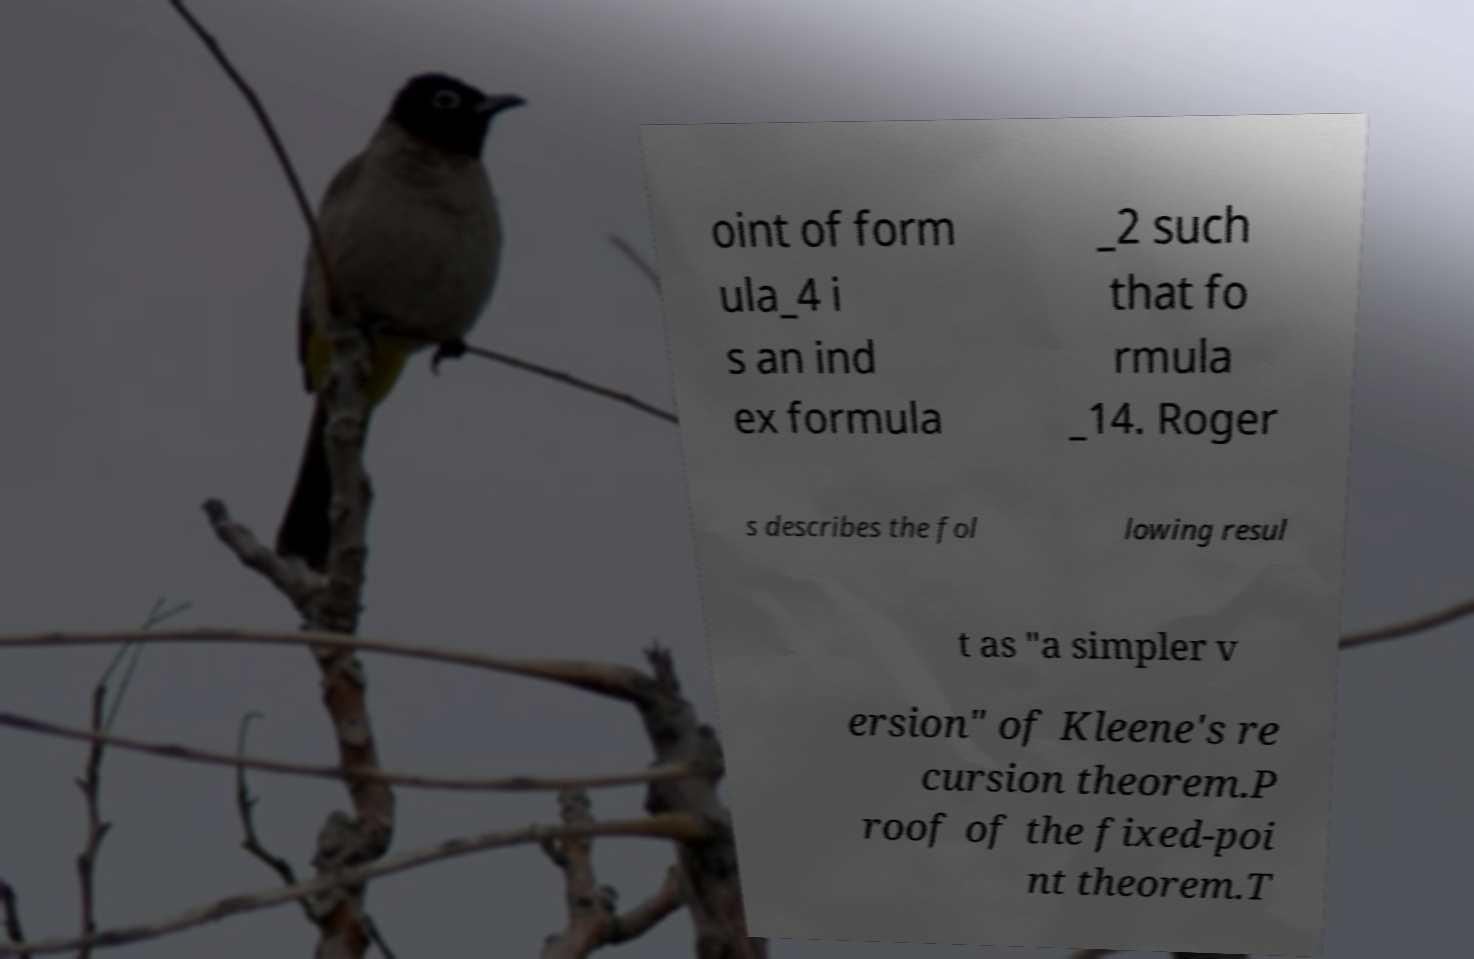Can you read and provide the text displayed in the image?This photo seems to have some interesting text. Can you extract and type it out for me? oint of form ula_4 i s an ind ex formula _2 such that fo rmula _14. Roger s describes the fol lowing resul t as "a simpler v ersion" of Kleene's re cursion theorem.P roof of the fixed-poi nt theorem.T 